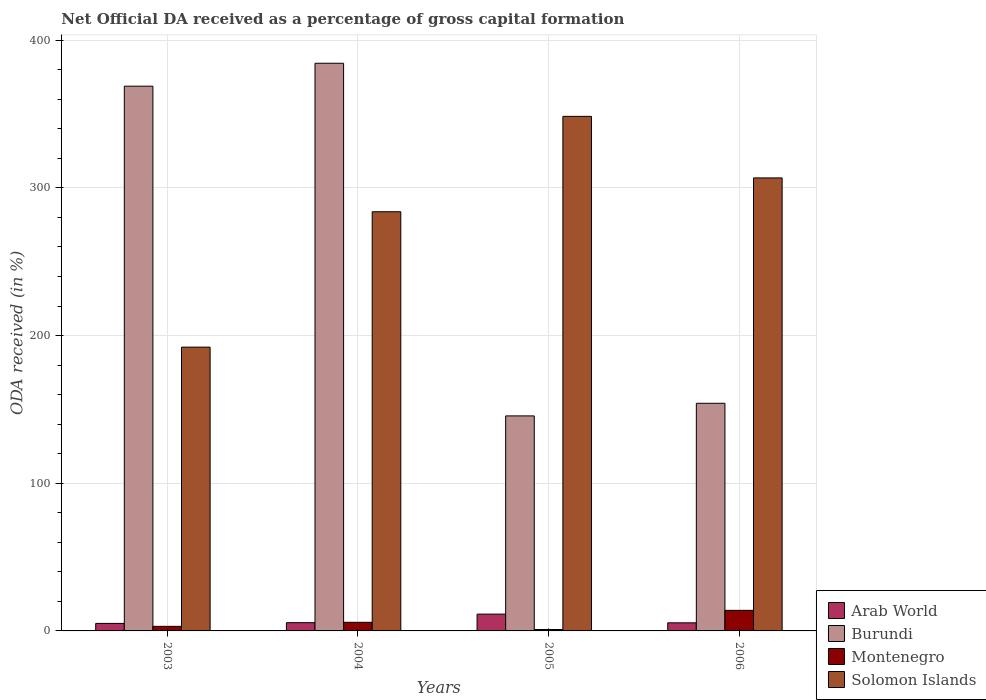How many different coloured bars are there?
Ensure brevity in your answer.  4. Are the number of bars per tick equal to the number of legend labels?
Your answer should be very brief. Yes. How many bars are there on the 2nd tick from the left?
Provide a succinct answer. 4. In how many cases, is the number of bars for a given year not equal to the number of legend labels?
Ensure brevity in your answer.  0. What is the net ODA received in Burundi in 2004?
Provide a succinct answer. 384.4. Across all years, what is the maximum net ODA received in Burundi?
Give a very brief answer. 384.4. Across all years, what is the minimum net ODA received in Solomon Islands?
Keep it short and to the point. 192.17. What is the total net ODA received in Burundi in the graph?
Ensure brevity in your answer.  1053.04. What is the difference between the net ODA received in Montenegro in 2004 and that in 2005?
Your answer should be compact. 4.87. What is the difference between the net ODA received in Burundi in 2003 and the net ODA received in Montenegro in 2006?
Ensure brevity in your answer.  354.95. What is the average net ODA received in Solomon Islands per year?
Offer a very short reply. 282.81. In the year 2005, what is the difference between the net ODA received in Montenegro and net ODA received in Arab World?
Provide a succinct answer. -10.42. What is the ratio of the net ODA received in Arab World in 2004 to that in 2006?
Provide a short and direct response. 1.02. Is the difference between the net ODA received in Montenegro in 2003 and 2005 greater than the difference between the net ODA received in Arab World in 2003 and 2005?
Your answer should be compact. Yes. What is the difference between the highest and the second highest net ODA received in Burundi?
Keep it short and to the point. 15.52. What is the difference between the highest and the lowest net ODA received in Arab World?
Offer a terse response. 6.3. What does the 4th bar from the left in 2005 represents?
Your response must be concise. Solomon Islands. What does the 2nd bar from the right in 2004 represents?
Ensure brevity in your answer.  Montenegro. How many bars are there?
Ensure brevity in your answer.  16. What is the difference between two consecutive major ticks on the Y-axis?
Keep it short and to the point. 100. Does the graph contain any zero values?
Provide a succinct answer. No. Does the graph contain grids?
Provide a succinct answer. Yes. Where does the legend appear in the graph?
Give a very brief answer. Bottom right. How many legend labels are there?
Give a very brief answer. 4. What is the title of the graph?
Offer a very short reply. Net Official DA received as a percentage of gross capital formation. Does "Heavily indebted poor countries" appear as one of the legend labels in the graph?
Offer a very short reply. No. What is the label or title of the X-axis?
Provide a short and direct response. Years. What is the label or title of the Y-axis?
Make the answer very short. ODA received (in %). What is the ODA received (in %) in Arab World in 2003?
Provide a short and direct response. 5.08. What is the ODA received (in %) in Burundi in 2003?
Keep it short and to the point. 368.89. What is the ODA received (in %) in Montenegro in 2003?
Provide a succinct answer. 3.09. What is the ODA received (in %) of Solomon Islands in 2003?
Your answer should be very brief. 192.17. What is the ODA received (in %) of Arab World in 2004?
Make the answer very short. 5.58. What is the ODA received (in %) in Burundi in 2004?
Offer a terse response. 384.4. What is the ODA received (in %) in Montenegro in 2004?
Keep it short and to the point. 5.84. What is the ODA received (in %) of Solomon Islands in 2004?
Your response must be concise. 283.85. What is the ODA received (in %) in Arab World in 2005?
Your answer should be very brief. 11.38. What is the ODA received (in %) of Burundi in 2005?
Offer a very short reply. 145.61. What is the ODA received (in %) in Montenegro in 2005?
Your answer should be compact. 0.96. What is the ODA received (in %) of Solomon Islands in 2005?
Offer a very short reply. 348.44. What is the ODA received (in %) in Arab World in 2006?
Provide a short and direct response. 5.49. What is the ODA received (in %) in Burundi in 2006?
Provide a short and direct response. 154.15. What is the ODA received (in %) in Montenegro in 2006?
Provide a short and direct response. 13.93. What is the ODA received (in %) in Solomon Islands in 2006?
Provide a short and direct response. 306.76. Across all years, what is the maximum ODA received (in %) of Arab World?
Your answer should be compact. 11.38. Across all years, what is the maximum ODA received (in %) of Burundi?
Offer a terse response. 384.4. Across all years, what is the maximum ODA received (in %) of Montenegro?
Ensure brevity in your answer.  13.93. Across all years, what is the maximum ODA received (in %) in Solomon Islands?
Your answer should be compact. 348.44. Across all years, what is the minimum ODA received (in %) in Arab World?
Give a very brief answer. 5.08. Across all years, what is the minimum ODA received (in %) in Burundi?
Make the answer very short. 145.61. Across all years, what is the minimum ODA received (in %) of Montenegro?
Make the answer very short. 0.96. Across all years, what is the minimum ODA received (in %) of Solomon Islands?
Offer a terse response. 192.17. What is the total ODA received (in %) of Arab World in the graph?
Provide a succinct answer. 27.53. What is the total ODA received (in %) of Burundi in the graph?
Your response must be concise. 1053.04. What is the total ODA received (in %) of Montenegro in the graph?
Make the answer very short. 23.83. What is the total ODA received (in %) of Solomon Islands in the graph?
Your answer should be compact. 1131.23. What is the difference between the ODA received (in %) in Arab World in 2003 and that in 2004?
Provide a short and direct response. -0.49. What is the difference between the ODA received (in %) in Burundi in 2003 and that in 2004?
Provide a short and direct response. -15.52. What is the difference between the ODA received (in %) in Montenegro in 2003 and that in 2004?
Your answer should be very brief. -2.75. What is the difference between the ODA received (in %) of Solomon Islands in 2003 and that in 2004?
Ensure brevity in your answer.  -91.68. What is the difference between the ODA received (in %) of Arab World in 2003 and that in 2005?
Your response must be concise. -6.3. What is the difference between the ODA received (in %) of Burundi in 2003 and that in 2005?
Give a very brief answer. 223.28. What is the difference between the ODA received (in %) in Montenegro in 2003 and that in 2005?
Provide a succinct answer. 2.13. What is the difference between the ODA received (in %) of Solomon Islands in 2003 and that in 2005?
Provide a succinct answer. -156.27. What is the difference between the ODA received (in %) of Arab World in 2003 and that in 2006?
Provide a short and direct response. -0.4. What is the difference between the ODA received (in %) of Burundi in 2003 and that in 2006?
Provide a short and direct response. 214.74. What is the difference between the ODA received (in %) of Montenegro in 2003 and that in 2006?
Provide a short and direct response. -10.84. What is the difference between the ODA received (in %) in Solomon Islands in 2003 and that in 2006?
Your answer should be very brief. -114.59. What is the difference between the ODA received (in %) in Arab World in 2004 and that in 2005?
Provide a short and direct response. -5.81. What is the difference between the ODA received (in %) in Burundi in 2004 and that in 2005?
Your response must be concise. 238.8. What is the difference between the ODA received (in %) in Montenegro in 2004 and that in 2005?
Your answer should be very brief. 4.87. What is the difference between the ODA received (in %) in Solomon Islands in 2004 and that in 2005?
Make the answer very short. -64.58. What is the difference between the ODA received (in %) in Arab World in 2004 and that in 2006?
Provide a short and direct response. 0.09. What is the difference between the ODA received (in %) in Burundi in 2004 and that in 2006?
Provide a short and direct response. 230.26. What is the difference between the ODA received (in %) of Montenegro in 2004 and that in 2006?
Provide a succinct answer. -8.1. What is the difference between the ODA received (in %) of Solomon Islands in 2004 and that in 2006?
Your response must be concise. -22.91. What is the difference between the ODA received (in %) in Arab World in 2005 and that in 2006?
Provide a short and direct response. 5.89. What is the difference between the ODA received (in %) in Burundi in 2005 and that in 2006?
Your response must be concise. -8.54. What is the difference between the ODA received (in %) in Montenegro in 2005 and that in 2006?
Offer a terse response. -12.97. What is the difference between the ODA received (in %) in Solomon Islands in 2005 and that in 2006?
Make the answer very short. 41.68. What is the difference between the ODA received (in %) of Arab World in 2003 and the ODA received (in %) of Burundi in 2004?
Keep it short and to the point. -379.32. What is the difference between the ODA received (in %) in Arab World in 2003 and the ODA received (in %) in Montenegro in 2004?
Give a very brief answer. -0.75. What is the difference between the ODA received (in %) in Arab World in 2003 and the ODA received (in %) in Solomon Islands in 2004?
Make the answer very short. -278.77. What is the difference between the ODA received (in %) in Burundi in 2003 and the ODA received (in %) in Montenegro in 2004?
Keep it short and to the point. 363.05. What is the difference between the ODA received (in %) of Burundi in 2003 and the ODA received (in %) of Solomon Islands in 2004?
Make the answer very short. 85.03. What is the difference between the ODA received (in %) of Montenegro in 2003 and the ODA received (in %) of Solomon Islands in 2004?
Your response must be concise. -280.76. What is the difference between the ODA received (in %) in Arab World in 2003 and the ODA received (in %) in Burundi in 2005?
Provide a short and direct response. -140.52. What is the difference between the ODA received (in %) in Arab World in 2003 and the ODA received (in %) in Montenegro in 2005?
Give a very brief answer. 4.12. What is the difference between the ODA received (in %) of Arab World in 2003 and the ODA received (in %) of Solomon Islands in 2005?
Make the answer very short. -343.36. What is the difference between the ODA received (in %) in Burundi in 2003 and the ODA received (in %) in Montenegro in 2005?
Provide a succinct answer. 367.92. What is the difference between the ODA received (in %) in Burundi in 2003 and the ODA received (in %) in Solomon Islands in 2005?
Provide a succinct answer. 20.45. What is the difference between the ODA received (in %) in Montenegro in 2003 and the ODA received (in %) in Solomon Islands in 2005?
Give a very brief answer. -345.35. What is the difference between the ODA received (in %) in Arab World in 2003 and the ODA received (in %) in Burundi in 2006?
Offer a terse response. -149.06. What is the difference between the ODA received (in %) of Arab World in 2003 and the ODA received (in %) of Montenegro in 2006?
Provide a succinct answer. -8.85. What is the difference between the ODA received (in %) of Arab World in 2003 and the ODA received (in %) of Solomon Islands in 2006?
Keep it short and to the point. -301.68. What is the difference between the ODA received (in %) of Burundi in 2003 and the ODA received (in %) of Montenegro in 2006?
Provide a short and direct response. 354.95. What is the difference between the ODA received (in %) of Burundi in 2003 and the ODA received (in %) of Solomon Islands in 2006?
Give a very brief answer. 62.12. What is the difference between the ODA received (in %) of Montenegro in 2003 and the ODA received (in %) of Solomon Islands in 2006?
Ensure brevity in your answer.  -303.67. What is the difference between the ODA received (in %) in Arab World in 2004 and the ODA received (in %) in Burundi in 2005?
Give a very brief answer. -140.03. What is the difference between the ODA received (in %) of Arab World in 2004 and the ODA received (in %) of Montenegro in 2005?
Provide a succinct answer. 4.61. What is the difference between the ODA received (in %) in Arab World in 2004 and the ODA received (in %) in Solomon Islands in 2005?
Provide a succinct answer. -342.86. What is the difference between the ODA received (in %) of Burundi in 2004 and the ODA received (in %) of Montenegro in 2005?
Make the answer very short. 383.44. What is the difference between the ODA received (in %) of Burundi in 2004 and the ODA received (in %) of Solomon Islands in 2005?
Offer a terse response. 35.96. What is the difference between the ODA received (in %) in Montenegro in 2004 and the ODA received (in %) in Solomon Islands in 2005?
Provide a succinct answer. -342.6. What is the difference between the ODA received (in %) of Arab World in 2004 and the ODA received (in %) of Burundi in 2006?
Keep it short and to the point. -148.57. What is the difference between the ODA received (in %) of Arab World in 2004 and the ODA received (in %) of Montenegro in 2006?
Your response must be concise. -8.36. What is the difference between the ODA received (in %) of Arab World in 2004 and the ODA received (in %) of Solomon Islands in 2006?
Give a very brief answer. -301.19. What is the difference between the ODA received (in %) in Burundi in 2004 and the ODA received (in %) in Montenegro in 2006?
Provide a succinct answer. 370.47. What is the difference between the ODA received (in %) of Burundi in 2004 and the ODA received (in %) of Solomon Islands in 2006?
Provide a short and direct response. 77.64. What is the difference between the ODA received (in %) in Montenegro in 2004 and the ODA received (in %) in Solomon Islands in 2006?
Your answer should be very brief. -300.93. What is the difference between the ODA received (in %) of Arab World in 2005 and the ODA received (in %) of Burundi in 2006?
Provide a succinct answer. -142.76. What is the difference between the ODA received (in %) in Arab World in 2005 and the ODA received (in %) in Montenegro in 2006?
Your answer should be very brief. -2.55. What is the difference between the ODA received (in %) in Arab World in 2005 and the ODA received (in %) in Solomon Islands in 2006?
Your answer should be compact. -295.38. What is the difference between the ODA received (in %) in Burundi in 2005 and the ODA received (in %) in Montenegro in 2006?
Offer a terse response. 131.67. What is the difference between the ODA received (in %) in Burundi in 2005 and the ODA received (in %) in Solomon Islands in 2006?
Ensure brevity in your answer.  -161.16. What is the difference between the ODA received (in %) of Montenegro in 2005 and the ODA received (in %) of Solomon Islands in 2006?
Give a very brief answer. -305.8. What is the average ODA received (in %) in Arab World per year?
Your response must be concise. 6.88. What is the average ODA received (in %) of Burundi per year?
Keep it short and to the point. 263.26. What is the average ODA received (in %) in Montenegro per year?
Offer a terse response. 5.96. What is the average ODA received (in %) in Solomon Islands per year?
Your answer should be very brief. 282.81. In the year 2003, what is the difference between the ODA received (in %) in Arab World and ODA received (in %) in Burundi?
Your answer should be compact. -363.8. In the year 2003, what is the difference between the ODA received (in %) of Arab World and ODA received (in %) of Montenegro?
Give a very brief answer. 1.99. In the year 2003, what is the difference between the ODA received (in %) of Arab World and ODA received (in %) of Solomon Islands?
Ensure brevity in your answer.  -187.09. In the year 2003, what is the difference between the ODA received (in %) of Burundi and ODA received (in %) of Montenegro?
Your answer should be compact. 365.79. In the year 2003, what is the difference between the ODA received (in %) of Burundi and ODA received (in %) of Solomon Islands?
Your answer should be compact. 176.72. In the year 2003, what is the difference between the ODA received (in %) in Montenegro and ODA received (in %) in Solomon Islands?
Offer a terse response. -189.08. In the year 2004, what is the difference between the ODA received (in %) of Arab World and ODA received (in %) of Burundi?
Keep it short and to the point. -378.83. In the year 2004, what is the difference between the ODA received (in %) in Arab World and ODA received (in %) in Montenegro?
Your answer should be compact. -0.26. In the year 2004, what is the difference between the ODA received (in %) in Arab World and ODA received (in %) in Solomon Islands?
Offer a terse response. -278.28. In the year 2004, what is the difference between the ODA received (in %) in Burundi and ODA received (in %) in Montenegro?
Keep it short and to the point. 378.57. In the year 2004, what is the difference between the ODA received (in %) of Burundi and ODA received (in %) of Solomon Islands?
Provide a short and direct response. 100.55. In the year 2004, what is the difference between the ODA received (in %) in Montenegro and ODA received (in %) in Solomon Islands?
Your answer should be very brief. -278.02. In the year 2005, what is the difference between the ODA received (in %) in Arab World and ODA received (in %) in Burundi?
Provide a short and direct response. -134.22. In the year 2005, what is the difference between the ODA received (in %) of Arab World and ODA received (in %) of Montenegro?
Your response must be concise. 10.42. In the year 2005, what is the difference between the ODA received (in %) of Arab World and ODA received (in %) of Solomon Islands?
Ensure brevity in your answer.  -337.06. In the year 2005, what is the difference between the ODA received (in %) in Burundi and ODA received (in %) in Montenegro?
Make the answer very short. 144.64. In the year 2005, what is the difference between the ODA received (in %) in Burundi and ODA received (in %) in Solomon Islands?
Your answer should be compact. -202.83. In the year 2005, what is the difference between the ODA received (in %) in Montenegro and ODA received (in %) in Solomon Islands?
Offer a terse response. -347.47. In the year 2006, what is the difference between the ODA received (in %) of Arab World and ODA received (in %) of Burundi?
Provide a succinct answer. -148.66. In the year 2006, what is the difference between the ODA received (in %) of Arab World and ODA received (in %) of Montenegro?
Provide a short and direct response. -8.45. In the year 2006, what is the difference between the ODA received (in %) in Arab World and ODA received (in %) in Solomon Islands?
Provide a short and direct response. -301.28. In the year 2006, what is the difference between the ODA received (in %) in Burundi and ODA received (in %) in Montenegro?
Your answer should be very brief. 140.21. In the year 2006, what is the difference between the ODA received (in %) in Burundi and ODA received (in %) in Solomon Islands?
Make the answer very short. -152.62. In the year 2006, what is the difference between the ODA received (in %) in Montenegro and ODA received (in %) in Solomon Islands?
Make the answer very short. -292.83. What is the ratio of the ODA received (in %) of Arab World in 2003 to that in 2004?
Provide a short and direct response. 0.91. What is the ratio of the ODA received (in %) of Burundi in 2003 to that in 2004?
Offer a very short reply. 0.96. What is the ratio of the ODA received (in %) of Montenegro in 2003 to that in 2004?
Your answer should be very brief. 0.53. What is the ratio of the ODA received (in %) in Solomon Islands in 2003 to that in 2004?
Keep it short and to the point. 0.68. What is the ratio of the ODA received (in %) of Arab World in 2003 to that in 2005?
Your answer should be very brief. 0.45. What is the ratio of the ODA received (in %) in Burundi in 2003 to that in 2005?
Ensure brevity in your answer.  2.53. What is the ratio of the ODA received (in %) of Montenegro in 2003 to that in 2005?
Keep it short and to the point. 3.21. What is the ratio of the ODA received (in %) in Solomon Islands in 2003 to that in 2005?
Your response must be concise. 0.55. What is the ratio of the ODA received (in %) of Arab World in 2003 to that in 2006?
Make the answer very short. 0.93. What is the ratio of the ODA received (in %) in Burundi in 2003 to that in 2006?
Your answer should be compact. 2.39. What is the ratio of the ODA received (in %) of Montenegro in 2003 to that in 2006?
Ensure brevity in your answer.  0.22. What is the ratio of the ODA received (in %) of Solomon Islands in 2003 to that in 2006?
Your response must be concise. 0.63. What is the ratio of the ODA received (in %) of Arab World in 2004 to that in 2005?
Make the answer very short. 0.49. What is the ratio of the ODA received (in %) in Burundi in 2004 to that in 2005?
Keep it short and to the point. 2.64. What is the ratio of the ODA received (in %) of Montenegro in 2004 to that in 2005?
Offer a terse response. 6.05. What is the ratio of the ODA received (in %) in Solomon Islands in 2004 to that in 2005?
Offer a very short reply. 0.81. What is the ratio of the ODA received (in %) of Arab World in 2004 to that in 2006?
Offer a very short reply. 1.02. What is the ratio of the ODA received (in %) of Burundi in 2004 to that in 2006?
Ensure brevity in your answer.  2.49. What is the ratio of the ODA received (in %) in Montenegro in 2004 to that in 2006?
Make the answer very short. 0.42. What is the ratio of the ODA received (in %) in Solomon Islands in 2004 to that in 2006?
Your answer should be compact. 0.93. What is the ratio of the ODA received (in %) of Arab World in 2005 to that in 2006?
Offer a terse response. 2.07. What is the ratio of the ODA received (in %) in Burundi in 2005 to that in 2006?
Offer a very short reply. 0.94. What is the ratio of the ODA received (in %) of Montenegro in 2005 to that in 2006?
Your response must be concise. 0.07. What is the ratio of the ODA received (in %) in Solomon Islands in 2005 to that in 2006?
Provide a short and direct response. 1.14. What is the difference between the highest and the second highest ODA received (in %) of Arab World?
Offer a very short reply. 5.81. What is the difference between the highest and the second highest ODA received (in %) of Burundi?
Offer a terse response. 15.52. What is the difference between the highest and the second highest ODA received (in %) of Montenegro?
Give a very brief answer. 8.1. What is the difference between the highest and the second highest ODA received (in %) in Solomon Islands?
Your answer should be very brief. 41.68. What is the difference between the highest and the lowest ODA received (in %) in Arab World?
Provide a short and direct response. 6.3. What is the difference between the highest and the lowest ODA received (in %) of Burundi?
Offer a terse response. 238.8. What is the difference between the highest and the lowest ODA received (in %) in Montenegro?
Provide a succinct answer. 12.97. What is the difference between the highest and the lowest ODA received (in %) of Solomon Islands?
Offer a very short reply. 156.27. 